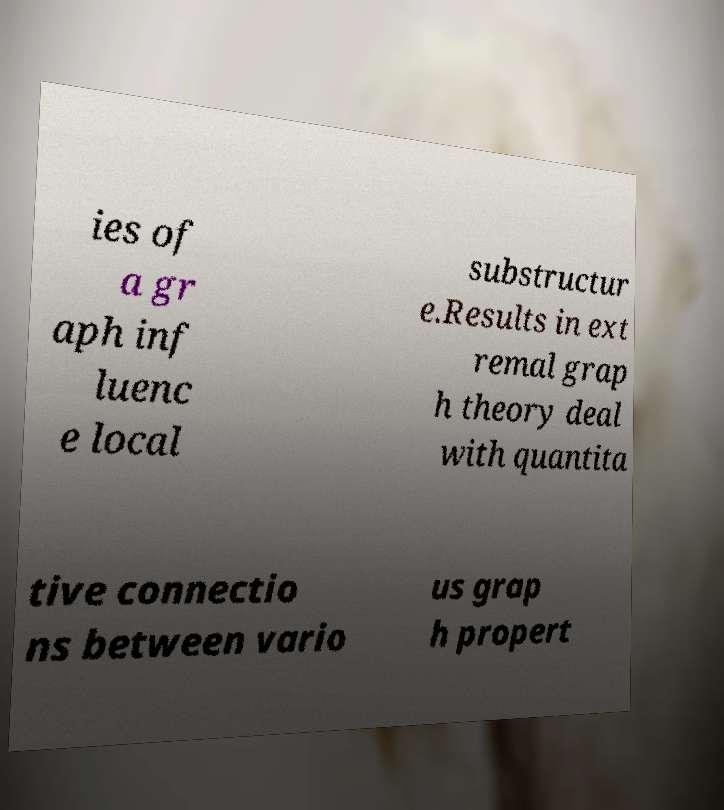Please read and relay the text visible in this image. What does it say? ies of a gr aph inf luenc e local substructur e.Results in ext remal grap h theory deal with quantita tive connectio ns between vario us grap h propert 